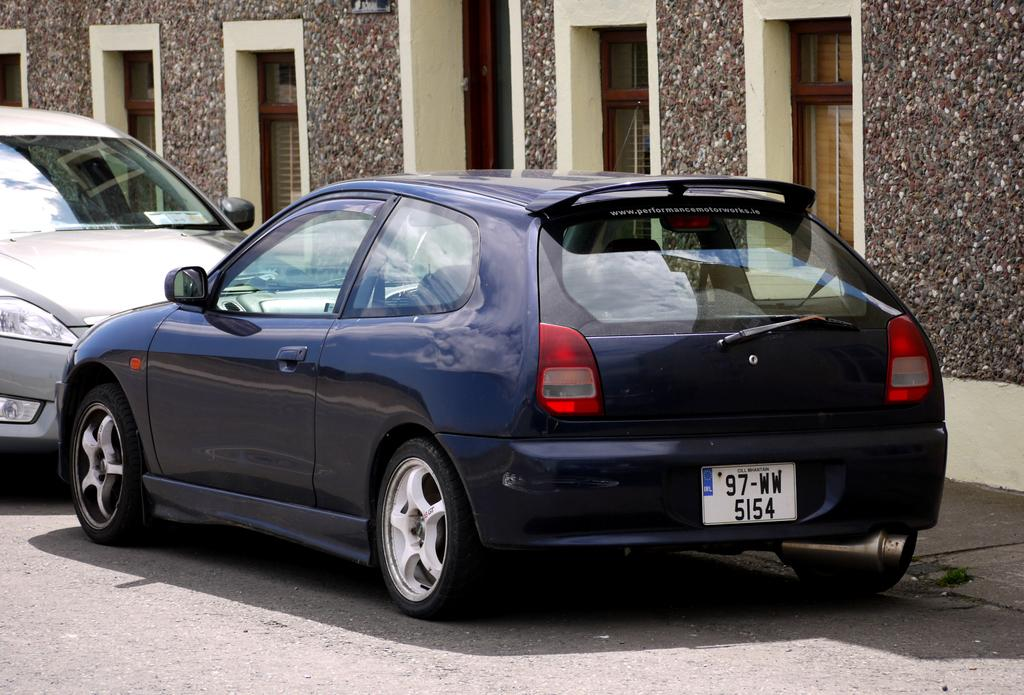How many cars are parked on the road in the image? There are two cars parked on the road in the image. What is located behind the cars? There is a building with windows behind the cars. Are there any goldfish swimming in the cars in the image? No, there are no goldfish present in the image, and they are not swimming in the cars. 